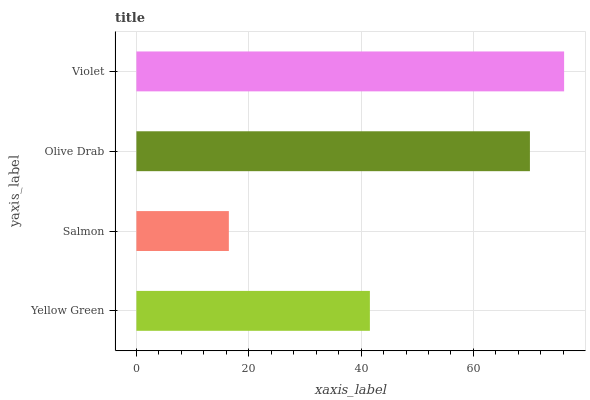Is Salmon the minimum?
Answer yes or no. Yes. Is Violet the maximum?
Answer yes or no. Yes. Is Olive Drab the minimum?
Answer yes or no. No. Is Olive Drab the maximum?
Answer yes or no. No. Is Olive Drab greater than Salmon?
Answer yes or no. Yes. Is Salmon less than Olive Drab?
Answer yes or no. Yes. Is Salmon greater than Olive Drab?
Answer yes or no. No. Is Olive Drab less than Salmon?
Answer yes or no. No. Is Olive Drab the high median?
Answer yes or no. Yes. Is Yellow Green the low median?
Answer yes or no. Yes. Is Yellow Green the high median?
Answer yes or no. No. Is Olive Drab the low median?
Answer yes or no. No. 